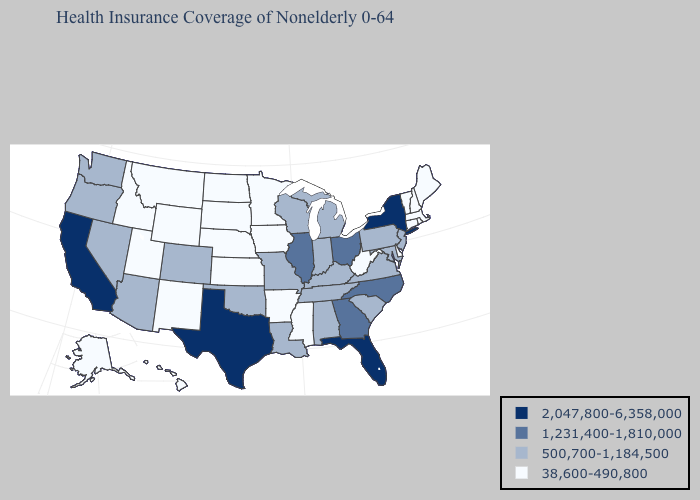Name the states that have a value in the range 500,700-1,184,500?
Quick response, please. Alabama, Arizona, Colorado, Indiana, Kentucky, Louisiana, Maryland, Michigan, Missouri, Nevada, New Jersey, Oklahoma, Oregon, Pennsylvania, South Carolina, Tennessee, Virginia, Washington, Wisconsin. Among the states that border Oklahoma , does Texas have the highest value?
Write a very short answer. Yes. What is the lowest value in the Northeast?
Quick response, please. 38,600-490,800. Does the first symbol in the legend represent the smallest category?
Keep it brief. No. Does New York have a higher value than California?
Write a very short answer. No. Name the states that have a value in the range 1,231,400-1,810,000?
Concise answer only. Georgia, Illinois, North Carolina, Ohio. Is the legend a continuous bar?
Keep it brief. No. Among the states that border Arkansas , which have the lowest value?
Concise answer only. Mississippi. Name the states that have a value in the range 500,700-1,184,500?
Give a very brief answer. Alabama, Arizona, Colorado, Indiana, Kentucky, Louisiana, Maryland, Michigan, Missouri, Nevada, New Jersey, Oklahoma, Oregon, Pennsylvania, South Carolina, Tennessee, Virginia, Washington, Wisconsin. Name the states that have a value in the range 2,047,800-6,358,000?
Be succinct. California, Florida, New York, Texas. Does Maryland have a lower value than North Carolina?
Concise answer only. Yes. Does Oklahoma have the lowest value in the USA?
Be succinct. No. What is the value of Nebraska?
Quick response, please. 38,600-490,800. What is the value of Mississippi?
Answer briefly. 38,600-490,800. Among the states that border Virginia , does West Virginia have the highest value?
Be succinct. No. 